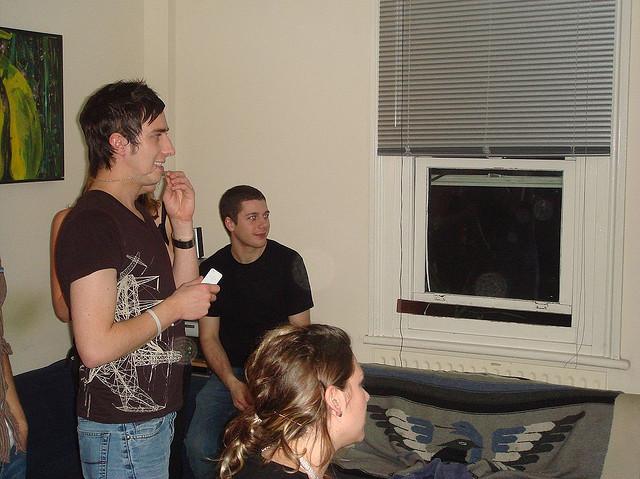What is the man on the left looking at?
Short answer required. Tv. Is the window open?
Concise answer only. Yes. Is he depressed?
Be succinct. No. What does the standing man have in his mouth?
Quick response, please. Necklace. What are the crouched people looking at?
Concise answer only. Tv. 